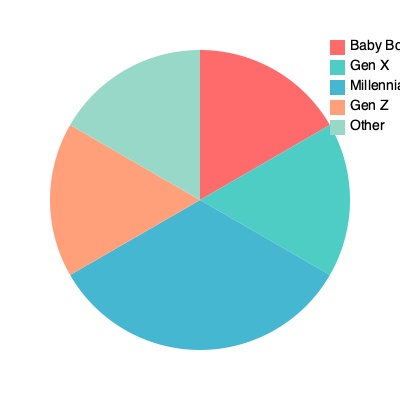The pie chart represents the primary media consumption preferences of different generations. If Millennials and Gen Z combined make up 50% of the total, what percentage does Gen X represent? To solve this problem, we need to follow these steps:

1. Identify the segments representing Millennials and Gen Z in the pie chart.
2. Observe that these two segments combined make up half of the circle (50%).
3. Count the total number of segments in the pie chart (5 segments).
4. Recognize that if Millennials and Gen Z make up 50%, the remaining 50% is divided among Baby Boomers, Gen X, and Other.
5. Notice that the Gen X segment appears to be equal in size to the Millennial segment.
6. Since Millennials and Gen Z combined make up 50%, and Gen X is equal to one of these segments, we can deduce that Gen X represents 25% of the total.

This question highlights the generational differences in media consumption habits, which is relevant to a marketing professional bringing modern perspectives to their parent's stories about the past. It requires analyzing visual data and making comparisons between different generational groups, skills that are valuable in marketing strategy development.
Answer: 25% 